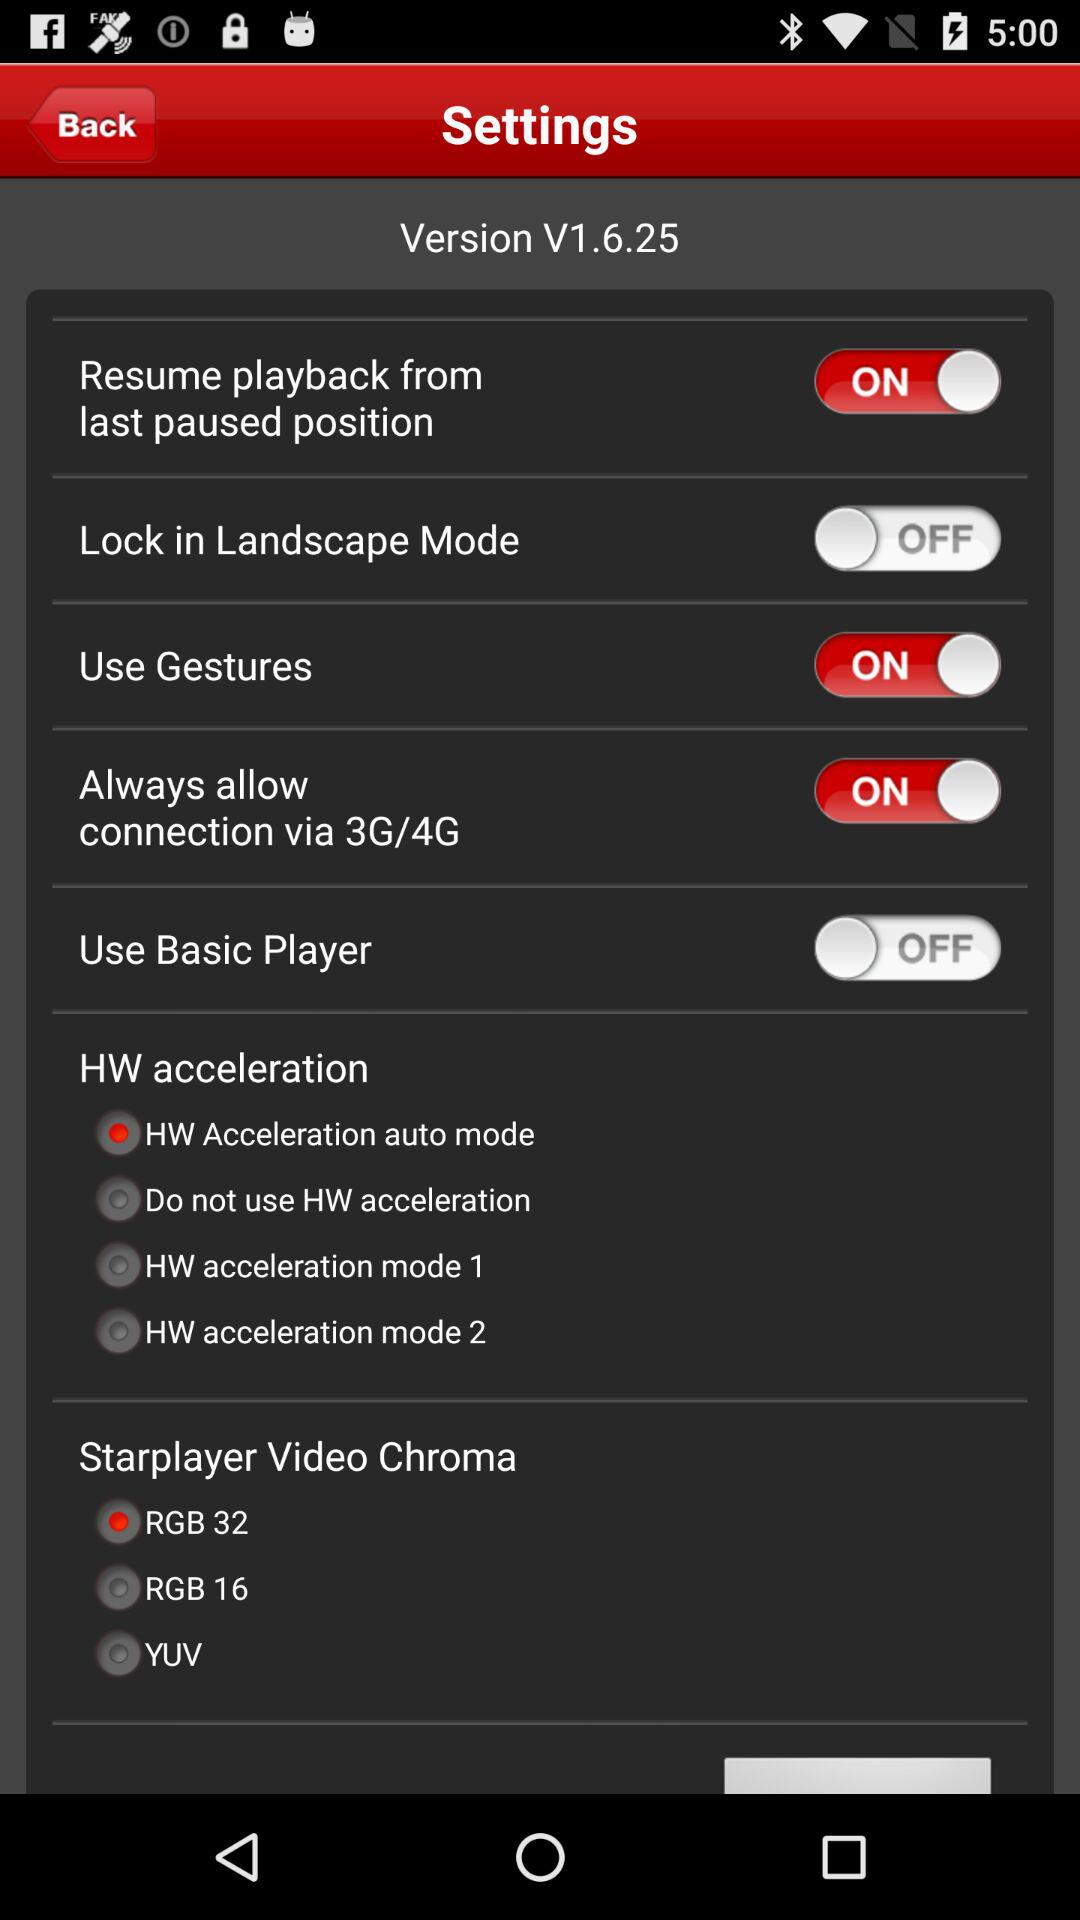For which setting is the "RGB 32" option selected? The "RGB 32" option is selected for the "Starplayer Video Chroma" setting. 